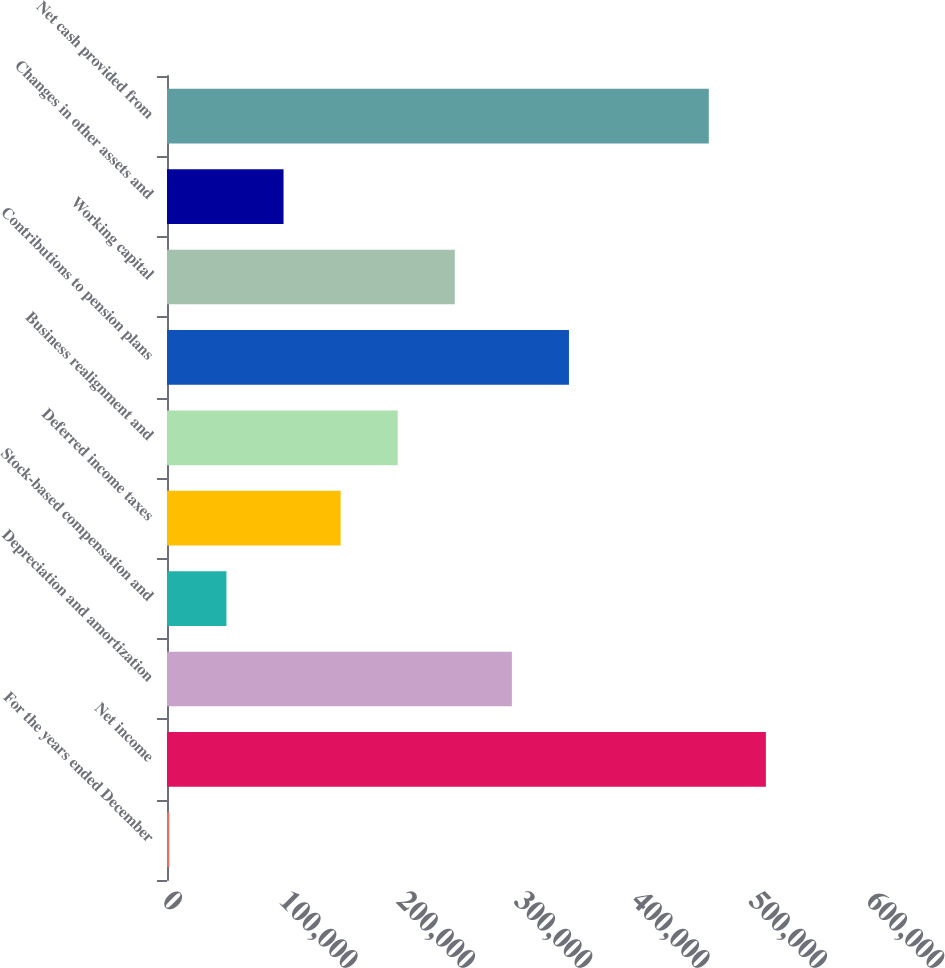<chart> <loc_0><loc_0><loc_500><loc_500><bar_chart><fcel>For the years ended December<fcel>Net income<fcel>Depreciation and amortization<fcel>Stock-based compensation and<fcel>Deferred income taxes<fcel>Business realignment and<fcel>Contributions to pension plans<fcel>Working capital<fcel>Changes in other assets and<fcel>Net cash provided from<nl><fcel>2005<fcel>510416<fcel>293930<fcel>50659.2<fcel>147968<fcel>196622<fcel>342584<fcel>245276<fcel>99313.4<fcel>461762<nl></chart> 